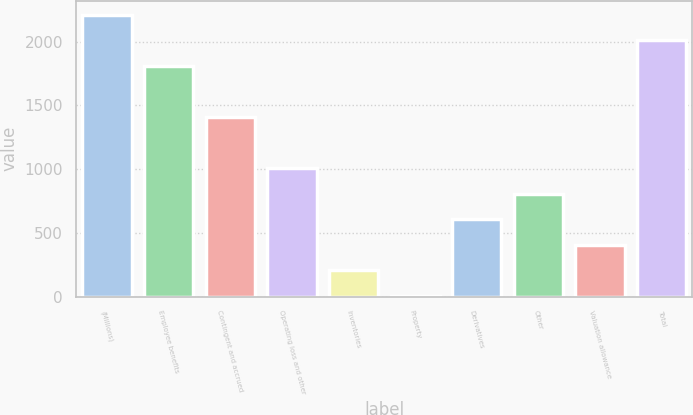Convert chart. <chart><loc_0><loc_0><loc_500><loc_500><bar_chart><fcel>(Millions)<fcel>Employee benefits<fcel>Contingent and accrued<fcel>Operating loss and other<fcel>Inventories<fcel>Property<fcel>Derivatives<fcel>Other<fcel>Valuation allowance<fcel>Total<nl><fcel>2209.3<fcel>1808.7<fcel>1408.1<fcel>1007.5<fcel>206.3<fcel>6<fcel>606.9<fcel>807.2<fcel>406.6<fcel>2009<nl></chart> 